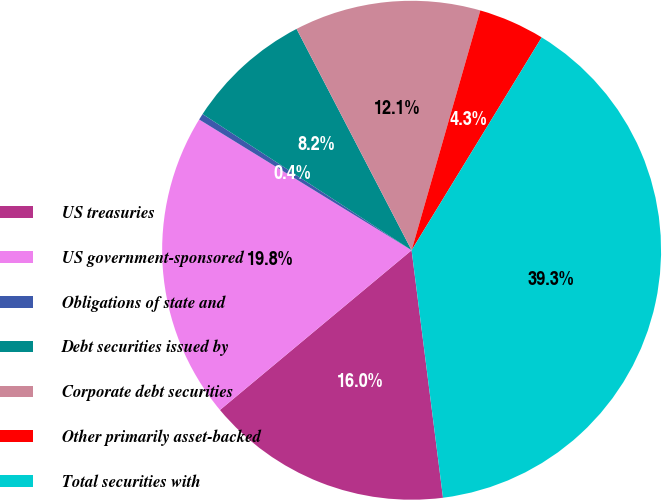Convert chart to OTSL. <chart><loc_0><loc_0><loc_500><loc_500><pie_chart><fcel>US treasuries<fcel>US government-sponsored<fcel>Obligations of state and<fcel>Debt securities issued by<fcel>Corporate debt securities<fcel>Other primarily asset-backed<fcel>Total securities with<nl><fcel>15.95%<fcel>19.84%<fcel>0.41%<fcel>8.18%<fcel>12.07%<fcel>4.29%<fcel>39.26%<nl></chart> 